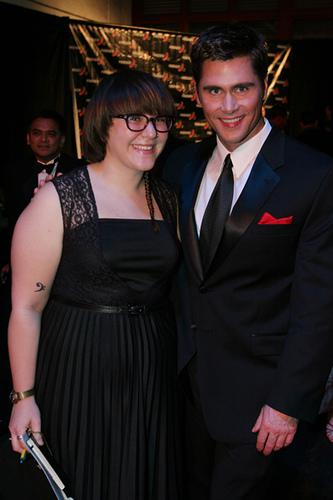Question: who is wearing a bow tie?
Choices:
A. The boy in green.
B. The old man in brown.
C. Young man in blue.
D. The man in the back.
Answer with the letter. Answer: D Question: how many people are in the picture?
Choices:
A. Four.
B. Five.
C. Three.
D. Six.
Answer with the letter. Answer: C Question: what wrist is the girls watch on?
Choices:
A. Her left.
B. Bottom right.
C. Bottom left.
D. Her right.
Answer with the letter. Answer: D Question: who is wearing eye glasses?
Choices:
A. The boy.
B. The girl.
C. The man.
D. The dog.
Answer with the letter. Answer: B Question: why are they smiling?
Choices:
A. They are happy.
B. They are sad.
C. They are angry.
D. They are relieved.
Answer with the letter. Answer: A Question: how many of the people are wearing suits?
Choices:
A. Eight.
B. Twelve.
C. Fifteen.
D. Two.
Answer with the letter. Answer: D 